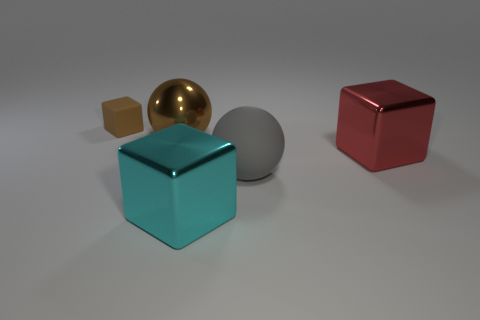Add 5 big cyan metallic cubes. How many objects exist? 10 Subtract all blocks. How many objects are left? 2 Subtract all large blocks. Subtract all yellow rubber things. How many objects are left? 3 Add 4 red metallic blocks. How many red metallic blocks are left? 5 Add 2 brown metal cylinders. How many brown metal cylinders exist? 2 Subtract 0 gray cubes. How many objects are left? 5 